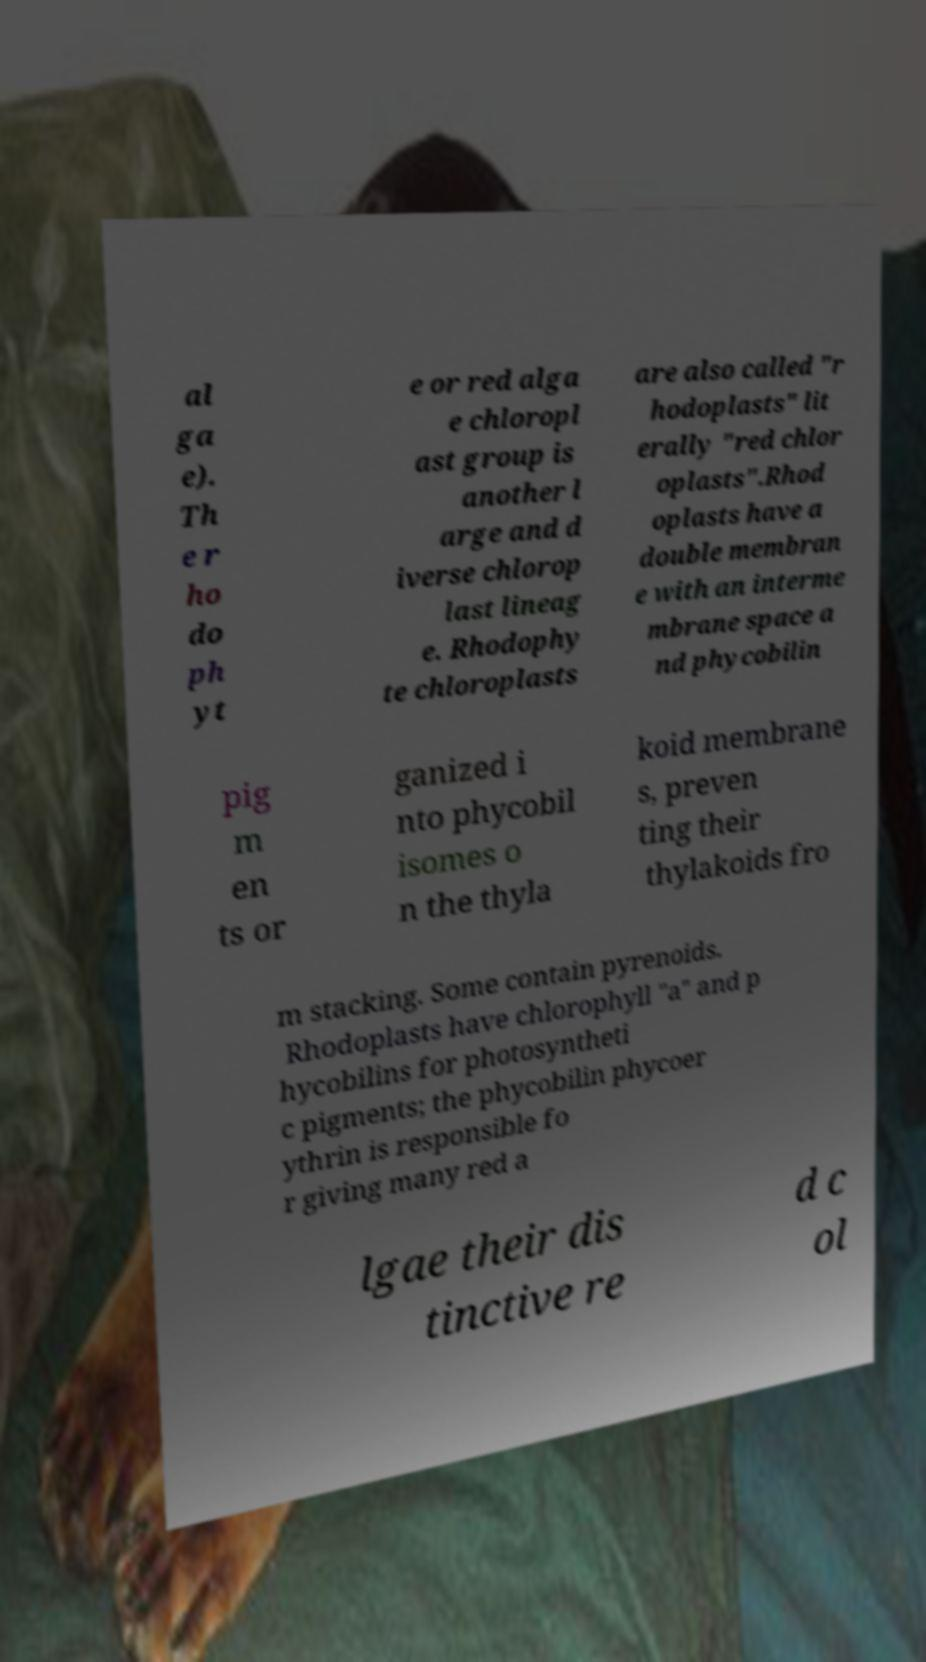What messages or text are displayed in this image? I need them in a readable, typed format. al ga e). Th e r ho do ph yt e or red alga e chloropl ast group is another l arge and d iverse chlorop last lineag e. Rhodophy te chloroplasts are also called "r hodoplasts" lit erally "red chlor oplasts".Rhod oplasts have a double membran e with an interme mbrane space a nd phycobilin pig m en ts or ganized i nto phycobil isomes o n the thyla koid membrane s, preven ting their thylakoids fro m stacking. Some contain pyrenoids. Rhodoplasts have chlorophyll "a" and p hycobilins for photosyntheti c pigments; the phycobilin phycoer ythrin is responsible fo r giving many red a lgae their dis tinctive re d c ol 